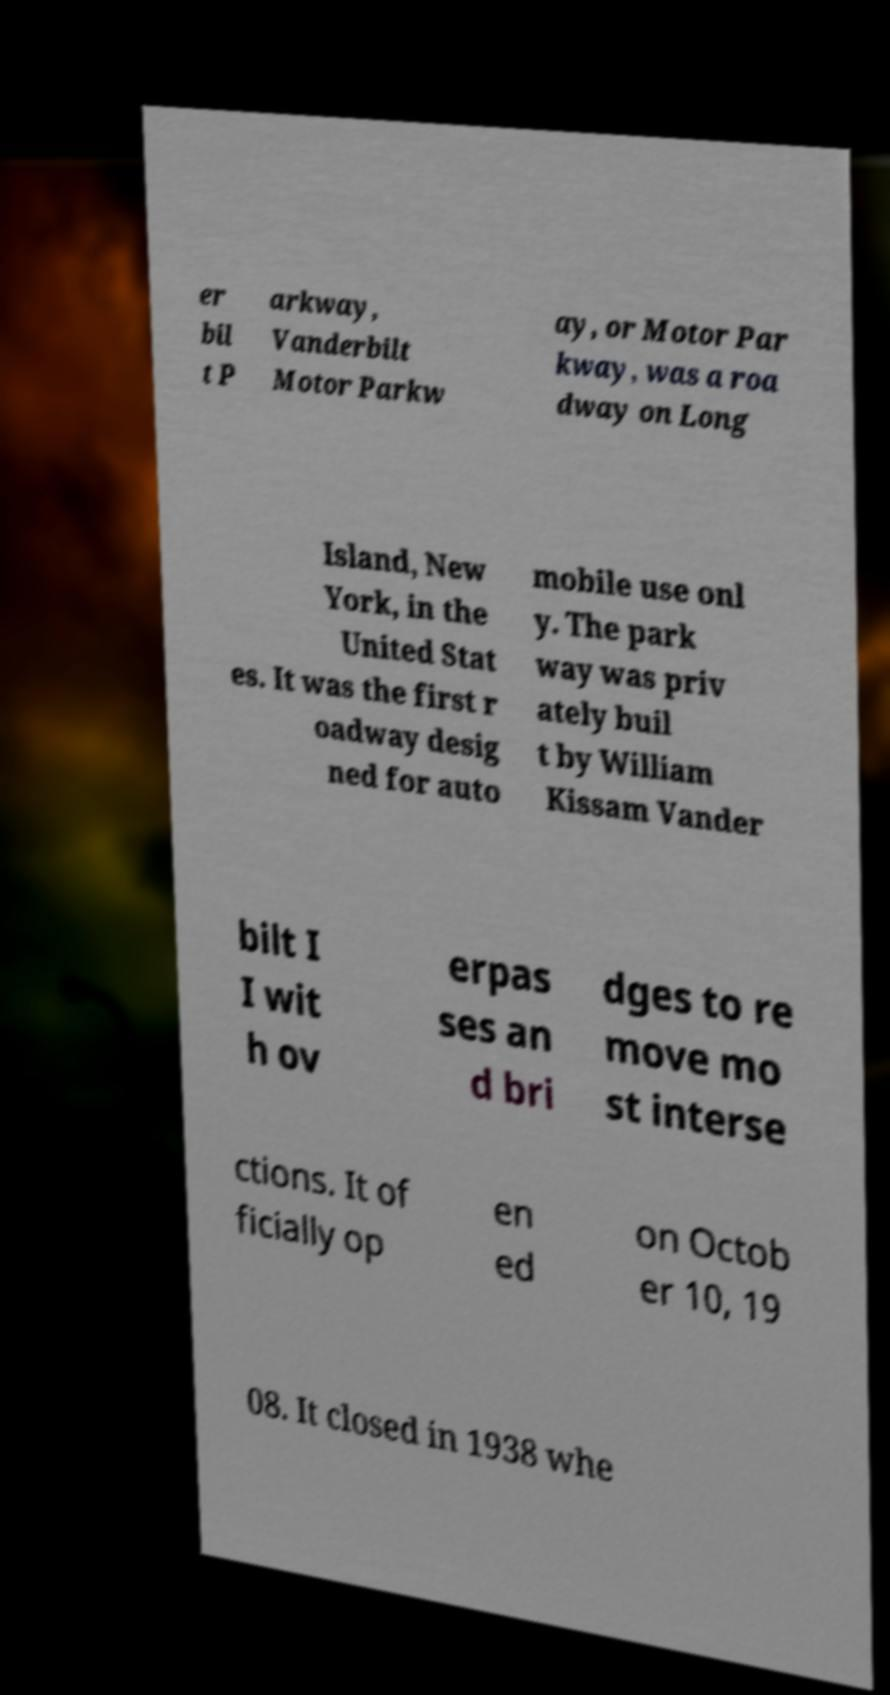What messages or text are displayed in this image? I need them in a readable, typed format. er bil t P arkway, Vanderbilt Motor Parkw ay, or Motor Par kway, was a roa dway on Long Island, New York, in the United Stat es. It was the first r oadway desig ned for auto mobile use onl y. The park way was priv ately buil t by William Kissam Vander bilt I I wit h ov erpas ses an d bri dges to re move mo st interse ctions. It of ficially op en ed on Octob er 10, 19 08. It closed in 1938 whe 